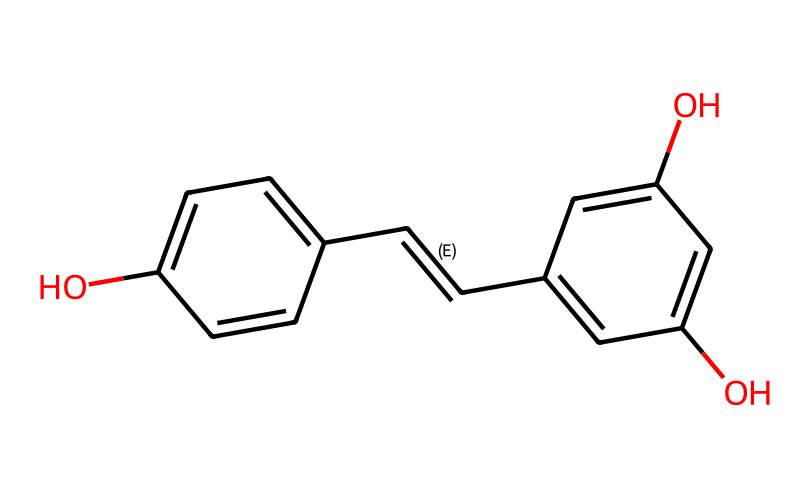What is the molecular weight of resveratrol? To find the molecular weight, we can sum the atomic weights of all the atoms represented in the SMILES notation. Resveratrol has 14 carbon (C), 12 hydrogen (H), and 4 oxygen (O) atoms. Using the approximate atomic weights: C (12.01 g/mol), H (1.008 g/mol), and O (16.00 g/mol), we get: (14 * 12.01) + (12 * 1.008) + (4 * 16.00) = 228.25 g/mol.
Answer: 228 How many hydroxyl groups are in the resveratrol structure? The chemical structure indicates that a hydroxyl group (−OH) is present at two positions of the aromatic rings. We identify these by locating the O atoms connected with H. Thus, there are two hydroxyl groups in resveratrol.
Answer: two What is the main functional group in resveratrol that contributes to its antioxidant properties? The key functional group in resveratrol that confers antioxidant properties is the hydroxyl group (-OH). These groups can donate hydrogen atoms to free radicals, neutralizing them and preventing oxidation.
Answer: hydroxyl How many double bonds are present in the resveratrol structure? By inspecting the structure derived from the SMILES representation, we can identify one double bond in the trans configuration within the carbon chain and another between two carbons in the aromatic rings. This leads to a total of two double bonds in resveratrol.
Answer: two What is the overall geometry of the carbon backbone in resveratrol? The carbon backbone consists of both sp2 and sp2 hybridized carbons due to the presence of double bonds and aromatic rings. The presence of these double bonds and normal carbon-carbon single bonds leads to a planar structure for the aromatic components and a linear or planar formation overall.
Answer: planar In what type of food is resveratrol predominantly found? Resveratrol is primarily found in red wine, which is made from grapes that contain this antioxidant compound. It can also be found in smaller quantities in various other berries and nuts, but the predominant source is red wine.
Answer: red wine 